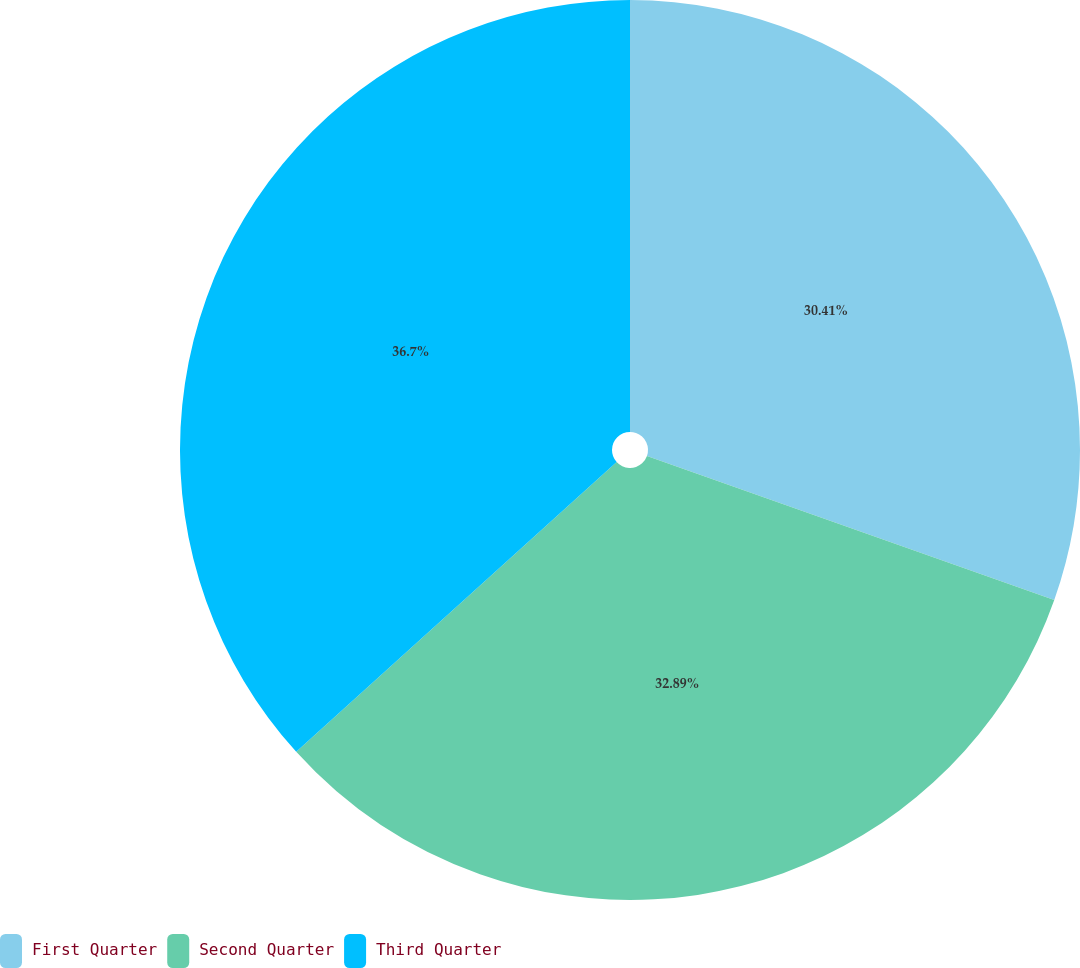Convert chart to OTSL. <chart><loc_0><loc_0><loc_500><loc_500><pie_chart><fcel>First Quarter<fcel>Second Quarter<fcel>Third Quarter<nl><fcel>30.41%<fcel>32.89%<fcel>36.7%<nl></chart> 